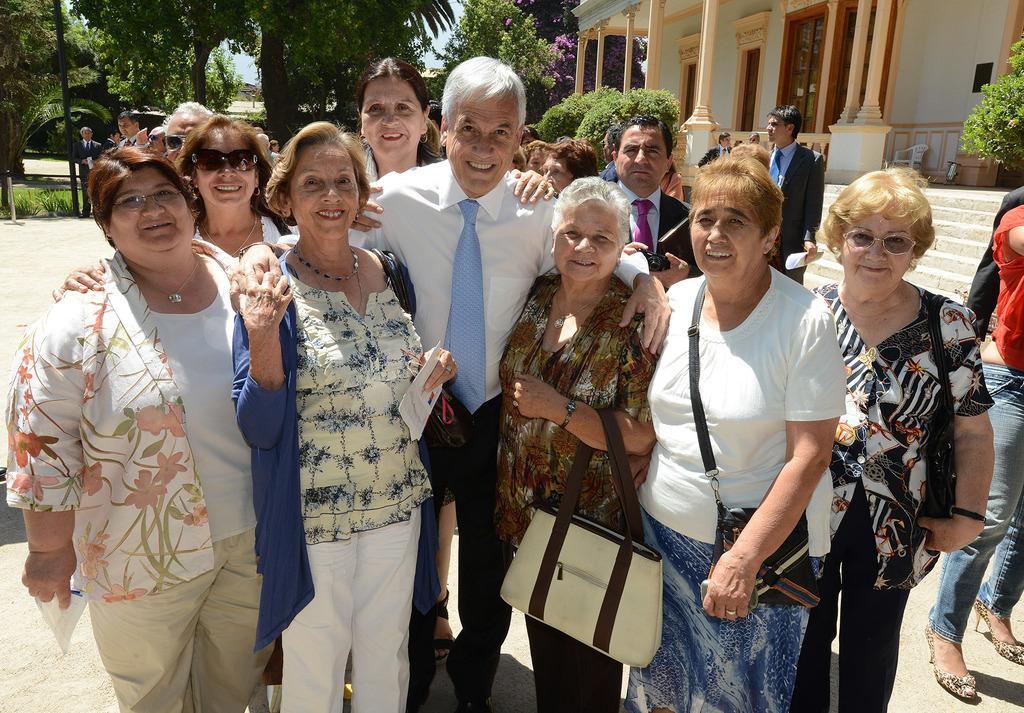Describe this image in one or two sentences. In this image we can see people standing. Some of them are holding papers. We can see bags. In the background there is a building and we can see bushes. There are trees and sky. 